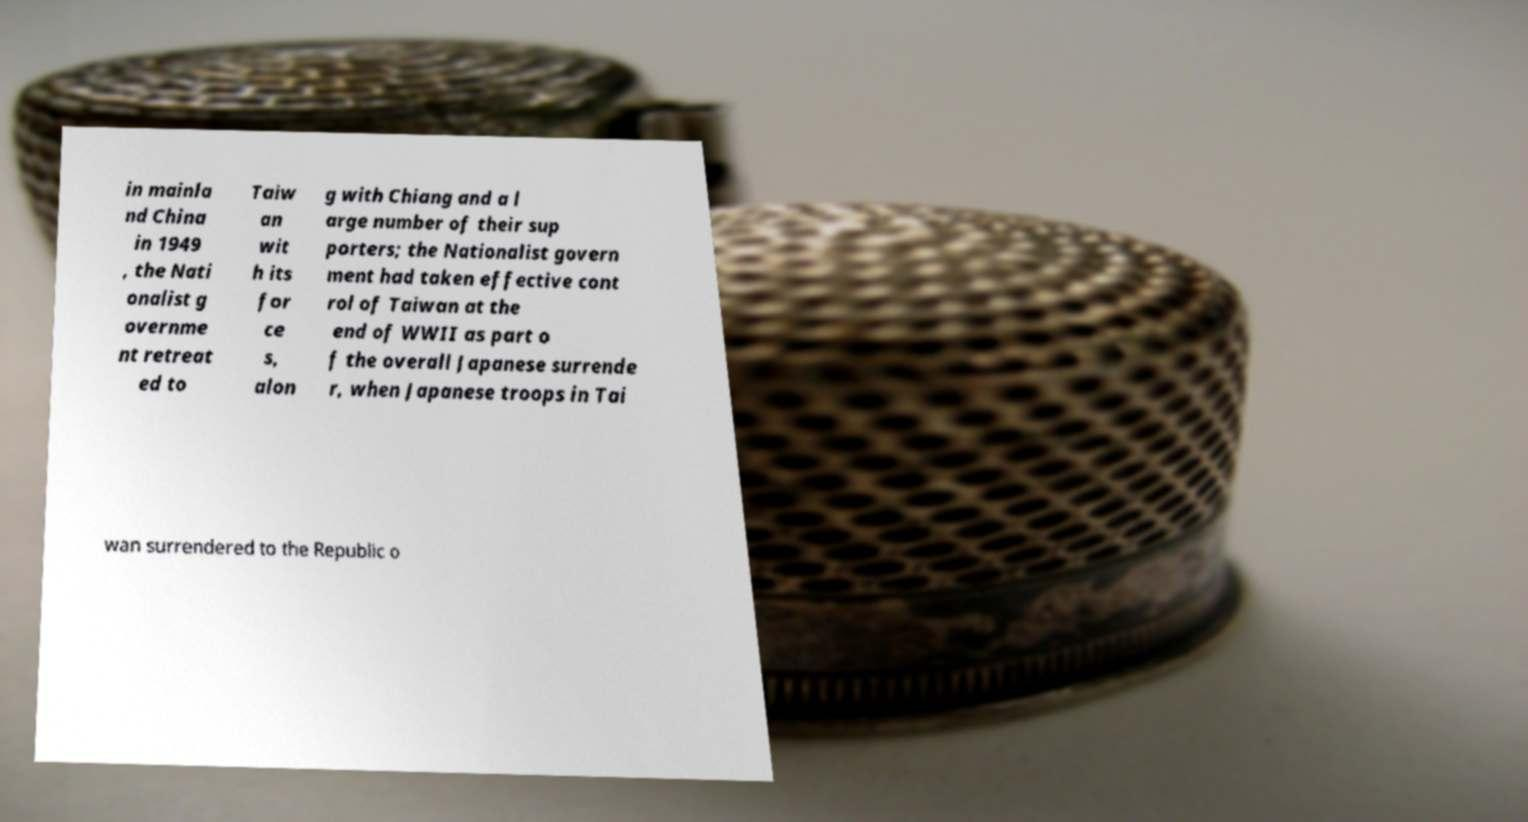What messages or text are displayed in this image? I need them in a readable, typed format. in mainla nd China in 1949 , the Nati onalist g overnme nt retreat ed to Taiw an wit h its for ce s, alon g with Chiang and a l arge number of their sup porters; the Nationalist govern ment had taken effective cont rol of Taiwan at the end of WWII as part o f the overall Japanese surrende r, when Japanese troops in Tai wan surrendered to the Republic o 